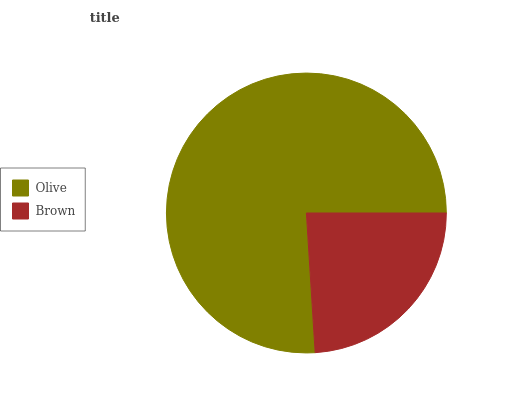Is Brown the minimum?
Answer yes or no. Yes. Is Olive the maximum?
Answer yes or no. Yes. Is Brown the maximum?
Answer yes or no. No. Is Olive greater than Brown?
Answer yes or no. Yes. Is Brown less than Olive?
Answer yes or no. Yes. Is Brown greater than Olive?
Answer yes or no. No. Is Olive less than Brown?
Answer yes or no. No. Is Olive the high median?
Answer yes or no. Yes. Is Brown the low median?
Answer yes or no. Yes. Is Brown the high median?
Answer yes or no. No. Is Olive the low median?
Answer yes or no. No. 